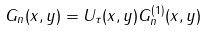<formula> <loc_0><loc_0><loc_500><loc_500>G _ { n } ( x , y ) = U _ { \tau } ( x , y ) G ^ { ( 1 ) } _ { n } ( x , y )</formula> 